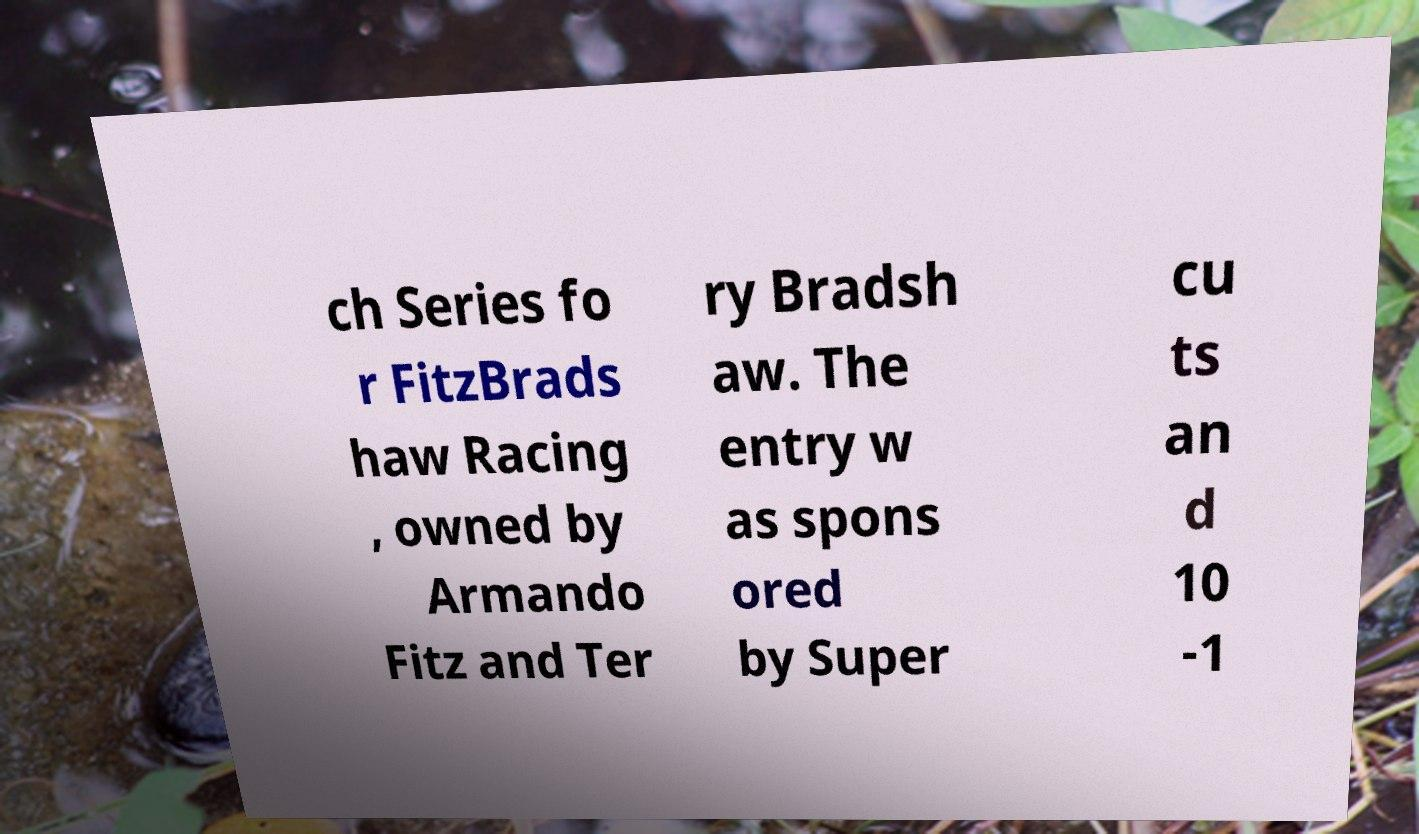For documentation purposes, I need the text within this image transcribed. Could you provide that? ch Series fo r FitzBrads haw Racing , owned by Armando Fitz and Ter ry Bradsh aw. The entry w as spons ored by Super cu ts an d 10 -1 